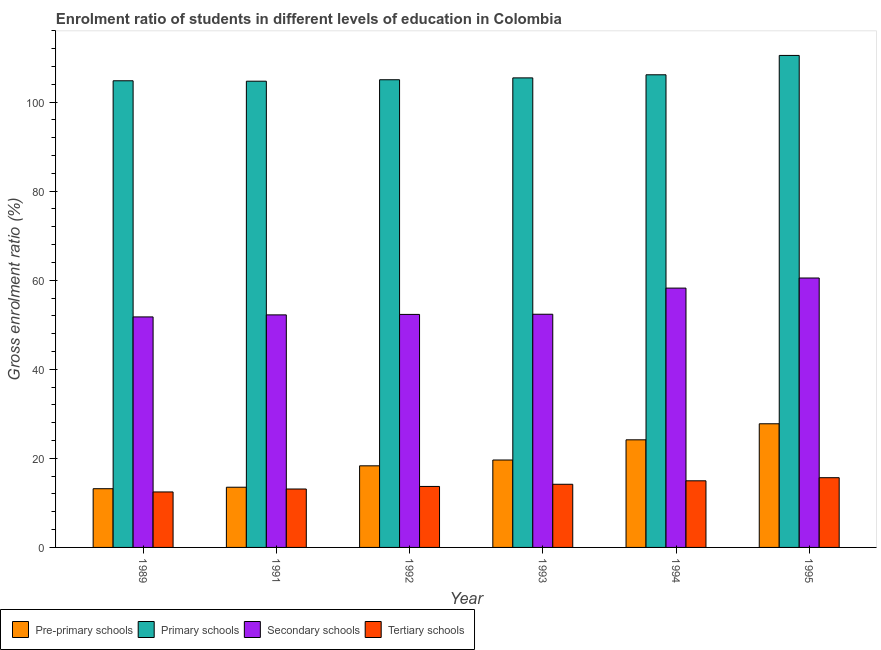How many groups of bars are there?
Offer a terse response. 6. Are the number of bars per tick equal to the number of legend labels?
Your answer should be compact. Yes. How many bars are there on the 3rd tick from the left?
Provide a succinct answer. 4. How many bars are there on the 3rd tick from the right?
Your answer should be compact. 4. What is the label of the 5th group of bars from the left?
Your answer should be compact. 1994. In how many cases, is the number of bars for a given year not equal to the number of legend labels?
Your response must be concise. 0. What is the gross enrolment ratio in tertiary schools in 1994?
Your answer should be compact. 14.96. Across all years, what is the maximum gross enrolment ratio in pre-primary schools?
Your response must be concise. 27.77. Across all years, what is the minimum gross enrolment ratio in secondary schools?
Your answer should be very brief. 51.76. What is the total gross enrolment ratio in secondary schools in the graph?
Your response must be concise. 327.41. What is the difference between the gross enrolment ratio in tertiary schools in 1989 and that in 1991?
Your response must be concise. -0.66. What is the difference between the gross enrolment ratio in tertiary schools in 1992 and the gross enrolment ratio in pre-primary schools in 1994?
Provide a short and direct response. -1.27. What is the average gross enrolment ratio in tertiary schools per year?
Your response must be concise. 14.01. In the year 1995, what is the difference between the gross enrolment ratio in primary schools and gross enrolment ratio in secondary schools?
Offer a very short reply. 0. What is the ratio of the gross enrolment ratio in primary schools in 1991 to that in 1992?
Your answer should be compact. 1. Is the difference between the gross enrolment ratio in pre-primary schools in 1991 and 1993 greater than the difference between the gross enrolment ratio in primary schools in 1991 and 1993?
Provide a short and direct response. No. What is the difference between the highest and the second highest gross enrolment ratio in secondary schools?
Your answer should be very brief. 2.27. What is the difference between the highest and the lowest gross enrolment ratio in secondary schools?
Your answer should be very brief. 8.74. What does the 2nd bar from the left in 1989 represents?
Your answer should be compact. Primary schools. What does the 1st bar from the right in 1995 represents?
Offer a terse response. Tertiary schools. Is it the case that in every year, the sum of the gross enrolment ratio in pre-primary schools and gross enrolment ratio in primary schools is greater than the gross enrolment ratio in secondary schools?
Give a very brief answer. Yes. How many bars are there?
Provide a short and direct response. 24. Are all the bars in the graph horizontal?
Offer a terse response. No. How many years are there in the graph?
Ensure brevity in your answer.  6. Are the values on the major ticks of Y-axis written in scientific E-notation?
Offer a terse response. No. Does the graph contain grids?
Offer a very short reply. No. How many legend labels are there?
Ensure brevity in your answer.  4. How are the legend labels stacked?
Provide a short and direct response. Horizontal. What is the title of the graph?
Make the answer very short. Enrolment ratio of students in different levels of education in Colombia. Does "Custom duties" appear as one of the legend labels in the graph?
Your response must be concise. No. What is the label or title of the X-axis?
Provide a succinct answer. Year. What is the Gross enrolment ratio (%) of Pre-primary schools in 1989?
Ensure brevity in your answer.  13.19. What is the Gross enrolment ratio (%) in Primary schools in 1989?
Your answer should be compact. 104.79. What is the Gross enrolment ratio (%) in Secondary schools in 1989?
Your answer should be very brief. 51.76. What is the Gross enrolment ratio (%) of Tertiary schools in 1989?
Provide a succinct answer. 12.46. What is the Gross enrolment ratio (%) of Pre-primary schools in 1991?
Give a very brief answer. 13.52. What is the Gross enrolment ratio (%) in Primary schools in 1991?
Ensure brevity in your answer.  104.7. What is the Gross enrolment ratio (%) in Secondary schools in 1991?
Keep it short and to the point. 52.22. What is the Gross enrolment ratio (%) in Tertiary schools in 1991?
Your answer should be very brief. 13.12. What is the Gross enrolment ratio (%) of Pre-primary schools in 1992?
Provide a short and direct response. 18.32. What is the Gross enrolment ratio (%) in Primary schools in 1992?
Give a very brief answer. 105.02. What is the Gross enrolment ratio (%) in Secondary schools in 1992?
Provide a succinct answer. 52.32. What is the Gross enrolment ratio (%) of Tertiary schools in 1992?
Offer a terse response. 13.69. What is the Gross enrolment ratio (%) in Pre-primary schools in 1993?
Offer a very short reply. 19.63. What is the Gross enrolment ratio (%) in Primary schools in 1993?
Offer a very short reply. 105.44. What is the Gross enrolment ratio (%) in Secondary schools in 1993?
Provide a succinct answer. 52.36. What is the Gross enrolment ratio (%) in Tertiary schools in 1993?
Your answer should be very brief. 14.18. What is the Gross enrolment ratio (%) in Pre-primary schools in 1994?
Your answer should be very brief. 24.17. What is the Gross enrolment ratio (%) in Primary schools in 1994?
Your response must be concise. 106.14. What is the Gross enrolment ratio (%) of Secondary schools in 1994?
Your response must be concise. 58.23. What is the Gross enrolment ratio (%) of Tertiary schools in 1994?
Make the answer very short. 14.96. What is the Gross enrolment ratio (%) of Pre-primary schools in 1995?
Ensure brevity in your answer.  27.77. What is the Gross enrolment ratio (%) in Primary schools in 1995?
Offer a very short reply. 110.49. What is the Gross enrolment ratio (%) in Secondary schools in 1995?
Provide a succinct answer. 60.5. What is the Gross enrolment ratio (%) of Tertiary schools in 1995?
Your answer should be very brief. 15.66. Across all years, what is the maximum Gross enrolment ratio (%) in Pre-primary schools?
Provide a succinct answer. 27.77. Across all years, what is the maximum Gross enrolment ratio (%) in Primary schools?
Ensure brevity in your answer.  110.49. Across all years, what is the maximum Gross enrolment ratio (%) of Secondary schools?
Provide a succinct answer. 60.5. Across all years, what is the maximum Gross enrolment ratio (%) of Tertiary schools?
Your answer should be very brief. 15.66. Across all years, what is the minimum Gross enrolment ratio (%) of Pre-primary schools?
Make the answer very short. 13.19. Across all years, what is the minimum Gross enrolment ratio (%) in Primary schools?
Offer a very short reply. 104.7. Across all years, what is the minimum Gross enrolment ratio (%) of Secondary schools?
Give a very brief answer. 51.76. Across all years, what is the minimum Gross enrolment ratio (%) in Tertiary schools?
Provide a succinct answer. 12.46. What is the total Gross enrolment ratio (%) in Pre-primary schools in the graph?
Offer a very short reply. 116.59. What is the total Gross enrolment ratio (%) in Primary schools in the graph?
Your answer should be very brief. 636.58. What is the total Gross enrolment ratio (%) of Secondary schools in the graph?
Offer a terse response. 327.41. What is the total Gross enrolment ratio (%) of Tertiary schools in the graph?
Your answer should be compact. 84.07. What is the difference between the Gross enrolment ratio (%) in Pre-primary schools in 1989 and that in 1991?
Your answer should be very brief. -0.33. What is the difference between the Gross enrolment ratio (%) of Primary schools in 1989 and that in 1991?
Your answer should be compact. 0.1. What is the difference between the Gross enrolment ratio (%) in Secondary schools in 1989 and that in 1991?
Provide a short and direct response. -0.46. What is the difference between the Gross enrolment ratio (%) of Tertiary schools in 1989 and that in 1991?
Keep it short and to the point. -0.66. What is the difference between the Gross enrolment ratio (%) in Pre-primary schools in 1989 and that in 1992?
Give a very brief answer. -5.14. What is the difference between the Gross enrolment ratio (%) in Primary schools in 1989 and that in 1992?
Your answer should be compact. -0.23. What is the difference between the Gross enrolment ratio (%) of Secondary schools in 1989 and that in 1992?
Provide a short and direct response. -0.56. What is the difference between the Gross enrolment ratio (%) of Tertiary schools in 1989 and that in 1992?
Offer a very short reply. -1.24. What is the difference between the Gross enrolment ratio (%) of Pre-primary schools in 1989 and that in 1993?
Offer a very short reply. -6.45. What is the difference between the Gross enrolment ratio (%) in Primary schools in 1989 and that in 1993?
Provide a succinct answer. -0.65. What is the difference between the Gross enrolment ratio (%) of Secondary schools in 1989 and that in 1993?
Your response must be concise. -0.6. What is the difference between the Gross enrolment ratio (%) in Tertiary schools in 1989 and that in 1993?
Your answer should be compact. -1.72. What is the difference between the Gross enrolment ratio (%) in Pre-primary schools in 1989 and that in 1994?
Offer a terse response. -10.98. What is the difference between the Gross enrolment ratio (%) in Primary schools in 1989 and that in 1994?
Offer a terse response. -1.34. What is the difference between the Gross enrolment ratio (%) of Secondary schools in 1989 and that in 1994?
Your answer should be very brief. -6.47. What is the difference between the Gross enrolment ratio (%) of Tertiary schools in 1989 and that in 1994?
Provide a succinct answer. -2.5. What is the difference between the Gross enrolment ratio (%) in Pre-primary schools in 1989 and that in 1995?
Your answer should be compact. -14.58. What is the difference between the Gross enrolment ratio (%) of Primary schools in 1989 and that in 1995?
Your answer should be very brief. -5.69. What is the difference between the Gross enrolment ratio (%) of Secondary schools in 1989 and that in 1995?
Your answer should be compact. -8.74. What is the difference between the Gross enrolment ratio (%) in Tertiary schools in 1989 and that in 1995?
Provide a short and direct response. -3.2. What is the difference between the Gross enrolment ratio (%) in Pre-primary schools in 1991 and that in 1992?
Keep it short and to the point. -4.8. What is the difference between the Gross enrolment ratio (%) of Primary schools in 1991 and that in 1992?
Your response must be concise. -0.32. What is the difference between the Gross enrolment ratio (%) in Secondary schools in 1991 and that in 1992?
Your response must be concise. -0.1. What is the difference between the Gross enrolment ratio (%) of Tertiary schools in 1991 and that in 1992?
Provide a succinct answer. -0.57. What is the difference between the Gross enrolment ratio (%) of Pre-primary schools in 1991 and that in 1993?
Your answer should be very brief. -6.11. What is the difference between the Gross enrolment ratio (%) in Primary schools in 1991 and that in 1993?
Keep it short and to the point. -0.74. What is the difference between the Gross enrolment ratio (%) of Secondary schools in 1991 and that in 1993?
Keep it short and to the point. -0.14. What is the difference between the Gross enrolment ratio (%) in Tertiary schools in 1991 and that in 1993?
Your answer should be compact. -1.06. What is the difference between the Gross enrolment ratio (%) of Pre-primary schools in 1991 and that in 1994?
Your answer should be very brief. -10.65. What is the difference between the Gross enrolment ratio (%) of Primary schools in 1991 and that in 1994?
Give a very brief answer. -1.44. What is the difference between the Gross enrolment ratio (%) in Secondary schools in 1991 and that in 1994?
Offer a very short reply. -6.02. What is the difference between the Gross enrolment ratio (%) in Tertiary schools in 1991 and that in 1994?
Your response must be concise. -1.84. What is the difference between the Gross enrolment ratio (%) in Pre-primary schools in 1991 and that in 1995?
Provide a short and direct response. -14.25. What is the difference between the Gross enrolment ratio (%) in Primary schools in 1991 and that in 1995?
Give a very brief answer. -5.79. What is the difference between the Gross enrolment ratio (%) of Secondary schools in 1991 and that in 1995?
Make the answer very short. -8.28. What is the difference between the Gross enrolment ratio (%) in Tertiary schools in 1991 and that in 1995?
Your response must be concise. -2.54. What is the difference between the Gross enrolment ratio (%) in Pre-primary schools in 1992 and that in 1993?
Provide a succinct answer. -1.31. What is the difference between the Gross enrolment ratio (%) of Primary schools in 1992 and that in 1993?
Make the answer very short. -0.42. What is the difference between the Gross enrolment ratio (%) of Secondary schools in 1992 and that in 1993?
Your response must be concise. -0.04. What is the difference between the Gross enrolment ratio (%) in Tertiary schools in 1992 and that in 1993?
Offer a very short reply. -0.49. What is the difference between the Gross enrolment ratio (%) of Pre-primary schools in 1992 and that in 1994?
Keep it short and to the point. -5.84. What is the difference between the Gross enrolment ratio (%) in Primary schools in 1992 and that in 1994?
Your answer should be very brief. -1.11. What is the difference between the Gross enrolment ratio (%) in Secondary schools in 1992 and that in 1994?
Your answer should be very brief. -5.91. What is the difference between the Gross enrolment ratio (%) in Tertiary schools in 1992 and that in 1994?
Offer a very short reply. -1.27. What is the difference between the Gross enrolment ratio (%) of Pre-primary schools in 1992 and that in 1995?
Your answer should be very brief. -9.44. What is the difference between the Gross enrolment ratio (%) of Primary schools in 1992 and that in 1995?
Your response must be concise. -5.46. What is the difference between the Gross enrolment ratio (%) of Secondary schools in 1992 and that in 1995?
Ensure brevity in your answer.  -8.18. What is the difference between the Gross enrolment ratio (%) in Tertiary schools in 1992 and that in 1995?
Keep it short and to the point. -1.97. What is the difference between the Gross enrolment ratio (%) in Pre-primary schools in 1993 and that in 1994?
Provide a succinct answer. -4.53. What is the difference between the Gross enrolment ratio (%) in Primary schools in 1993 and that in 1994?
Keep it short and to the point. -0.7. What is the difference between the Gross enrolment ratio (%) of Secondary schools in 1993 and that in 1994?
Give a very brief answer. -5.87. What is the difference between the Gross enrolment ratio (%) in Tertiary schools in 1993 and that in 1994?
Your answer should be very brief. -0.78. What is the difference between the Gross enrolment ratio (%) of Pre-primary schools in 1993 and that in 1995?
Your answer should be compact. -8.14. What is the difference between the Gross enrolment ratio (%) in Primary schools in 1993 and that in 1995?
Give a very brief answer. -5.04. What is the difference between the Gross enrolment ratio (%) of Secondary schools in 1993 and that in 1995?
Your response must be concise. -8.14. What is the difference between the Gross enrolment ratio (%) of Tertiary schools in 1993 and that in 1995?
Provide a short and direct response. -1.48. What is the difference between the Gross enrolment ratio (%) of Pre-primary schools in 1994 and that in 1995?
Your answer should be compact. -3.6. What is the difference between the Gross enrolment ratio (%) in Primary schools in 1994 and that in 1995?
Offer a terse response. -4.35. What is the difference between the Gross enrolment ratio (%) of Secondary schools in 1994 and that in 1995?
Your response must be concise. -2.27. What is the difference between the Gross enrolment ratio (%) in Tertiary schools in 1994 and that in 1995?
Make the answer very short. -0.7. What is the difference between the Gross enrolment ratio (%) of Pre-primary schools in 1989 and the Gross enrolment ratio (%) of Primary schools in 1991?
Make the answer very short. -91.51. What is the difference between the Gross enrolment ratio (%) of Pre-primary schools in 1989 and the Gross enrolment ratio (%) of Secondary schools in 1991?
Offer a terse response. -39.03. What is the difference between the Gross enrolment ratio (%) of Pre-primary schools in 1989 and the Gross enrolment ratio (%) of Tertiary schools in 1991?
Your answer should be very brief. 0.07. What is the difference between the Gross enrolment ratio (%) in Primary schools in 1989 and the Gross enrolment ratio (%) in Secondary schools in 1991?
Your answer should be very brief. 52.57. What is the difference between the Gross enrolment ratio (%) in Primary schools in 1989 and the Gross enrolment ratio (%) in Tertiary schools in 1991?
Ensure brevity in your answer.  91.68. What is the difference between the Gross enrolment ratio (%) in Secondary schools in 1989 and the Gross enrolment ratio (%) in Tertiary schools in 1991?
Your answer should be very brief. 38.65. What is the difference between the Gross enrolment ratio (%) in Pre-primary schools in 1989 and the Gross enrolment ratio (%) in Primary schools in 1992?
Make the answer very short. -91.84. What is the difference between the Gross enrolment ratio (%) in Pre-primary schools in 1989 and the Gross enrolment ratio (%) in Secondary schools in 1992?
Ensure brevity in your answer.  -39.14. What is the difference between the Gross enrolment ratio (%) of Pre-primary schools in 1989 and the Gross enrolment ratio (%) of Tertiary schools in 1992?
Provide a succinct answer. -0.51. What is the difference between the Gross enrolment ratio (%) of Primary schools in 1989 and the Gross enrolment ratio (%) of Secondary schools in 1992?
Keep it short and to the point. 52.47. What is the difference between the Gross enrolment ratio (%) of Primary schools in 1989 and the Gross enrolment ratio (%) of Tertiary schools in 1992?
Keep it short and to the point. 91.1. What is the difference between the Gross enrolment ratio (%) of Secondary schools in 1989 and the Gross enrolment ratio (%) of Tertiary schools in 1992?
Offer a terse response. 38.07. What is the difference between the Gross enrolment ratio (%) of Pre-primary schools in 1989 and the Gross enrolment ratio (%) of Primary schools in 1993?
Offer a terse response. -92.26. What is the difference between the Gross enrolment ratio (%) of Pre-primary schools in 1989 and the Gross enrolment ratio (%) of Secondary schools in 1993?
Provide a succinct answer. -39.18. What is the difference between the Gross enrolment ratio (%) of Pre-primary schools in 1989 and the Gross enrolment ratio (%) of Tertiary schools in 1993?
Make the answer very short. -1. What is the difference between the Gross enrolment ratio (%) of Primary schools in 1989 and the Gross enrolment ratio (%) of Secondary schools in 1993?
Give a very brief answer. 52.43. What is the difference between the Gross enrolment ratio (%) in Primary schools in 1989 and the Gross enrolment ratio (%) in Tertiary schools in 1993?
Keep it short and to the point. 90.61. What is the difference between the Gross enrolment ratio (%) of Secondary schools in 1989 and the Gross enrolment ratio (%) of Tertiary schools in 1993?
Your answer should be very brief. 37.58. What is the difference between the Gross enrolment ratio (%) in Pre-primary schools in 1989 and the Gross enrolment ratio (%) in Primary schools in 1994?
Offer a very short reply. -92.95. What is the difference between the Gross enrolment ratio (%) in Pre-primary schools in 1989 and the Gross enrolment ratio (%) in Secondary schools in 1994?
Your response must be concise. -45.05. What is the difference between the Gross enrolment ratio (%) of Pre-primary schools in 1989 and the Gross enrolment ratio (%) of Tertiary schools in 1994?
Keep it short and to the point. -1.78. What is the difference between the Gross enrolment ratio (%) of Primary schools in 1989 and the Gross enrolment ratio (%) of Secondary schools in 1994?
Provide a succinct answer. 46.56. What is the difference between the Gross enrolment ratio (%) of Primary schools in 1989 and the Gross enrolment ratio (%) of Tertiary schools in 1994?
Your answer should be very brief. 89.83. What is the difference between the Gross enrolment ratio (%) in Secondary schools in 1989 and the Gross enrolment ratio (%) in Tertiary schools in 1994?
Make the answer very short. 36.8. What is the difference between the Gross enrolment ratio (%) in Pre-primary schools in 1989 and the Gross enrolment ratio (%) in Primary schools in 1995?
Your answer should be compact. -97.3. What is the difference between the Gross enrolment ratio (%) in Pre-primary schools in 1989 and the Gross enrolment ratio (%) in Secondary schools in 1995?
Offer a very short reply. -47.32. What is the difference between the Gross enrolment ratio (%) of Pre-primary schools in 1989 and the Gross enrolment ratio (%) of Tertiary schools in 1995?
Ensure brevity in your answer.  -2.48. What is the difference between the Gross enrolment ratio (%) in Primary schools in 1989 and the Gross enrolment ratio (%) in Secondary schools in 1995?
Give a very brief answer. 44.29. What is the difference between the Gross enrolment ratio (%) in Primary schools in 1989 and the Gross enrolment ratio (%) in Tertiary schools in 1995?
Your response must be concise. 89.13. What is the difference between the Gross enrolment ratio (%) in Secondary schools in 1989 and the Gross enrolment ratio (%) in Tertiary schools in 1995?
Provide a succinct answer. 36.1. What is the difference between the Gross enrolment ratio (%) of Pre-primary schools in 1991 and the Gross enrolment ratio (%) of Primary schools in 1992?
Make the answer very short. -91.5. What is the difference between the Gross enrolment ratio (%) of Pre-primary schools in 1991 and the Gross enrolment ratio (%) of Secondary schools in 1992?
Make the answer very short. -38.8. What is the difference between the Gross enrolment ratio (%) of Pre-primary schools in 1991 and the Gross enrolment ratio (%) of Tertiary schools in 1992?
Your answer should be compact. -0.17. What is the difference between the Gross enrolment ratio (%) of Primary schools in 1991 and the Gross enrolment ratio (%) of Secondary schools in 1992?
Offer a very short reply. 52.37. What is the difference between the Gross enrolment ratio (%) in Primary schools in 1991 and the Gross enrolment ratio (%) in Tertiary schools in 1992?
Your answer should be compact. 91.01. What is the difference between the Gross enrolment ratio (%) in Secondary schools in 1991 and the Gross enrolment ratio (%) in Tertiary schools in 1992?
Give a very brief answer. 38.53. What is the difference between the Gross enrolment ratio (%) in Pre-primary schools in 1991 and the Gross enrolment ratio (%) in Primary schools in 1993?
Make the answer very short. -91.92. What is the difference between the Gross enrolment ratio (%) in Pre-primary schools in 1991 and the Gross enrolment ratio (%) in Secondary schools in 1993?
Offer a terse response. -38.84. What is the difference between the Gross enrolment ratio (%) in Pre-primary schools in 1991 and the Gross enrolment ratio (%) in Tertiary schools in 1993?
Give a very brief answer. -0.66. What is the difference between the Gross enrolment ratio (%) in Primary schools in 1991 and the Gross enrolment ratio (%) in Secondary schools in 1993?
Your answer should be compact. 52.33. What is the difference between the Gross enrolment ratio (%) in Primary schools in 1991 and the Gross enrolment ratio (%) in Tertiary schools in 1993?
Your answer should be compact. 90.52. What is the difference between the Gross enrolment ratio (%) in Secondary schools in 1991 and the Gross enrolment ratio (%) in Tertiary schools in 1993?
Your response must be concise. 38.04. What is the difference between the Gross enrolment ratio (%) in Pre-primary schools in 1991 and the Gross enrolment ratio (%) in Primary schools in 1994?
Your response must be concise. -92.62. What is the difference between the Gross enrolment ratio (%) in Pre-primary schools in 1991 and the Gross enrolment ratio (%) in Secondary schools in 1994?
Offer a very short reply. -44.71. What is the difference between the Gross enrolment ratio (%) of Pre-primary schools in 1991 and the Gross enrolment ratio (%) of Tertiary schools in 1994?
Provide a short and direct response. -1.44. What is the difference between the Gross enrolment ratio (%) in Primary schools in 1991 and the Gross enrolment ratio (%) in Secondary schools in 1994?
Offer a very short reply. 46.46. What is the difference between the Gross enrolment ratio (%) in Primary schools in 1991 and the Gross enrolment ratio (%) in Tertiary schools in 1994?
Offer a terse response. 89.74. What is the difference between the Gross enrolment ratio (%) in Secondary schools in 1991 and the Gross enrolment ratio (%) in Tertiary schools in 1994?
Your response must be concise. 37.26. What is the difference between the Gross enrolment ratio (%) in Pre-primary schools in 1991 and the Gross enrolment ratio (%) in Primary schools in 1995?
Give a very brief answer. -96.97. What is the difference between the Gross enrolment ratio (%) of Pre-primary schools in 1991 and the Gross enrolment ratio (%) of Secondary schools in 1995?
Make the answer very short. -46.98. What is the difference between the Gross enrolment ratio (%) of Pre-primary schools in 1991 and the Gross enrolment ratio (%) of Tertiary schools in 1995?
Your answer should be compact. -2.14. What is the difference between the Gross enrolment ratio (%) of Primary schools in 1991 and the Gross enrolment ratio (%) of Secondary schools in 1995?
Your answer should be very brief. 44.2. What is the difference between the Gross enrolment ratio (%) in Primary schools in 1991 and the Gross enrolment ratio (%) in Tertiary schools in 1995?
Provide a succinct answer. 89.04. What is the difference between the Gross enrolment ratio (%) in Secondary schools in 1991 and the Gross enrolment ratio (%) in Tertiary schools in 1995?
Your response must be concise. 36.56. What is the difference between the Gross enrolment ratio (%) of Pre-primary schools in 1992 and the Gross enrolment ratio (%) of Primary schools in 1993?
Offer a terse response. -87.12. What is the difference between the Gross enrolment ratio (%) in Pre-primary schools in 1992 and the Gross enrolment ratio (%) in Secondary schools in 1993?
Offer a terse response. -34.04. What is the difference between the Gross enrolment ratio (%) of Pre-primary schools in 1992 and the Gross enrolment ratio (%) of Tertiary schools in 1993?
Your response must be concise. 4.14. What is the difference between the Gross enrolment ratio (%) of Primary schools in 1992 and the Gross enrolment ratio (%) of Secondary schools in 1993?
Make the answer very short. 52.66. What is the difference between the Gross enrolment ratio (%) in Primary schools in 1992 and the Gross enrolment ratio (%) in Tertiary schools in 1993?
Your response must be concise. 90.84. What is the difference between the Gross enrolment ratio (%) in Secondary schools in 1992 and the Gross enrolment ratio (%) in Tertiary schools in 1993?
Ensure brevity in your answer.  38.14. What is the difference between the Gross enrolment ratio (%) in Pre-primary schools in 1992 and the Gross enrolment ratio (%) in Primary schools in 1994?
Make the answer very short. -87.81. What is the difference between the Gross enrolment ratio (%) of Pre-primary schools in 1992 and the Gross enrolment ratio (%) of Secondary schools in 1994?
Offer a terse response. -39.91. What is the difference between the Gross enrolment ratio (%) in Pre-primary schools in 1992 and the Gross enrolment ratio (%) in Tertiary schools in 1994?
Make the answer very short. 3.36. What is the difference between the Gross enrolment ratio (%) in Primary schools in 1992 and the Gross enrolment ratio (%) in Secondary schools in 1994?
Provide a short and direct response. 46.79. What is the difference between the Gross enrolment ratio (%) of Primary schools in 1992 and the Gross enrolment ratio (%) of Tertiary schools in 1994?
Your answer should be compact. 90.06. What is the difference between the Gross enrolment ratio (%) of Secondary schools in 1992 and the Gross enrolment ratio (%) of Tertiary schools in 1994?
Offer a very short reply. 37.36. What is the difference between the Gross enrolment ratio (%) in Pre-primary schools in 1992 and the Gross enrolment ratio (%) in Primary schools in 1995?
Make the answer very short. -92.16. What is the difference between the Gross enrolment ratio (%) in Pre-primary schools in 1992 and the Gross enrolment ratio (%) in Secondary schools in 1995?
Your answer should be compact. -42.18. What is the difference between the Gross enrolment ratio (%) of Pre-primary schools in 1992 and the Gross enrolment ratio (%) of Tertiary schools in 1995?
Keep it short and to the point. 2.66. What is the difference between the Gross enrolment ratio (%) of Primary schools in 1992 and the Gross enrolment ratio (%) of Secondary schools in 1995?
Keep it short and to the point. 44.52. What is the difference between the Gross enrolment ratio (%) in Primary schools in 1992 and the Gross enrolment ratio (%) in Tertiary schools in 1995?
Your response must be concise. 89.36. What is the difference between the Gross enrolment ratio (%) of Secondary schools in 1992 and the Gross enrolment ratio (%) of Tertiary schools in 1995?
Offer a very short reply. 36.66. What is the difference between the Gross enrolment ratio (%) of Pre-primary schools in 1993 and the Gross enrolment ratio (%) of Primary schools in 1994?
Keep it short and to the point. -86.5. What is the difference between the Gross enrolment ratio (%) in Pre-primary schools in 1993 and the Gross enrolment ratio (%) in Secondary schools in 1994?
Give a very brief answer. -38.6. What is the difference between the Gross enrolment ratio (%) in Pre-primary schools in 1993 and the Gross enrolment ratio (%) in Tertiary schools in 1994?
Your answer should be very brief. 4.67. What is the difference between the Gross enrolment ratio (%) in Primary schools in 1993 and the Gross enrolment ratio (%) in Secondary schools in 1994?
Your response must be concise. 47.21. What is the difference between the Gross enrolment ratio (%) of Primary schools in 1993 and the Gross enrolment ratio (%) of Tertiary schools in 1994?
Your response must be concise. 90.48. What is the difference between the Gross enrolment ratio (%) of Secondary schools in 1993 and the Gross enrolment ratio (%) of Tertiary schools in 1994?
Your answer should be very brief. 37.4. What is the difference between the Gross enrolment ratio (%) of Pre-primary schools in 1993 and the Gross enrolment ratio (%) of Primary schools in 1995?
Offer a terse response. -90.85. What is the difference between the Gross enrolment ratio (%) in Pre-primary schools in 1993 and the Gross enrolment ratio (%) in Secondary schools in 1995?
Ensure brevity in your answer.  -40.87. What is the difference between the Gross enrolment ratio (%) of Pre-primary schools in 1993 and the Gross enrolment ratio (%) of Tertiary schools in 1995?
Make the answer very short. 3.97. What is the difference between the Gross enrolment ratio (%) in Primary schools in 1993 and the Gross enrolment ratio (%) in Secondary schools in 1995?
Your answer should be compact. 44.94. What is the difference between the Gross enrolment ratio (%) in Primary schools in 1993 and the Gross enrolment ratio (%) in Tertiary schools in 1995?
Provide a succinct answer. 89.78. What is the difference between the Gross enrolment ratio (%) of Secondary schools in 1993 and the Gross enrolment ratio (%) of Tertiary schools in 1995?
Keep it short and to the point. 36.7. What is the difference between the Gross enrolment ratio (%) of Pre-primary schools in 1994 and the Gross enrolment ratio (%) of Primary schools in 1995?
Give a very brief answer. -86.32. What is the difference between the Gross enrolment ratio (%) in Pre-primary schools in 1994 and the Gross enrolment ratio (%) in Secondary schools in 1995?
Provide a succinct answer. -36.34. What is the difference between the Gross enrolment ratio (%) in Pre-primary schools in 1994 and the Gross enrolment ratio (%) in Tertiary schools in 1995?
Give a very brief answer. 8.5. What is the difference between the Gross enrolment ratio (%) of Primary schools in 1994 and the Gross enrolment ratio (%) of Secondary schools in 1995?
Your answer should be compact. 45.63. What is the difference between the Gross enrolment ratio (%) of Primary schools in 1994 and the Gross enrolment ratio (%) of Tertiary schools in 1995?
Offer a very short reply. 90.48. What is the difference between the Gross enrolment ratio (%) in Secondary schools in 1994 and the Gross enrolment ratio (%) in Tertiary schools in 1995?
Make the answer very short. 42.57. What is the average Gross enrolment ratio (%) in Pre-primary schools per year?
Your answer should be very brief. 19.43. What is the average Gross enrolment ratio (%) of Primary schools per year?
Provide a succinct answer. 106.1. What is the average Gross enrolment ratio (%) of Secondary schools per year?
Provide a short and direct response. 54.57. What is the average Gross enrolment ratio (%) in Tertiary schools per year?
Ensure brevity in your answer.  14.01. In the year 1989, what is the difference between the Gross enrolment ratio (%) of Pre-primary schools and Gross enrolment ratio (%) of Primary schools?
Make the answer very short. -91.61. In the year 1989, what is the difference between the Gross enrolment ratio (%) of Pre-primary schools and Gross enrolment ratio (%) of Secondary schools?
Your answer should be very brief. -38.58. In the year 1989, what is the difference between the Gross enrolment ratio (%) of Pre-primary schools and Gross enrolment ratio (%) of Tertiary schools?
Provide a succinct answer. 0.73. In the year 1989, what is the difference between the Gross enrolment ratio (%) of Primary schools and Gross enrolment ratio (%) of Secondary schools?
Provide a succinct answer. 53.03. In the year 1989, what is the difference between the Gross enrolment ratio (%) in Primary schools and Gross enrolment ratio (%) in Tertiary schools?
Offer a very short reply. 92.34. In the year 1989, what is the difference between the Gross enrolment ratio (%) in Secondary schools and Gross enrolment ratio (%) in Tertiary schools?
Keep it short and to the point. 39.31. In the year 1991, what is the difference between the Gross enrolment ratio (%) in Pre-primary schools and Gross enrolment ratio (%) in Primary schools?
Provide a succinct answer. -91.18. In the year 1991, what is the difference between the Gross enrolment ratio (%) of Pre-primary schools and Gross enrolment ratio (%) of Secondary schools?
Provide a succinct answer. -38.7. In the year 1991, what is the difference between the Gross enrolment ratio (%) in Pre-primary schools and Gross enrolment ratio (%) in Tertiary schools?
Keep it short and to the point. 0.4. In the year 1991, what is the difference between the Gross enrolment ratio (%) in Primary schools and Gross enrolment ratio (%) in Secondary schools?
Your answer should be very brief. 52.48. In the year 1991, what is the difference between the Gross enrolment ratio (%) of Primary schools and Gross enrolment ratio (%) of Tertiary schools?
Give a very brief answer. 91.58. In the year 1991, what is the difference between the Gross enrolment ratio (%) in Secondary schools and Gross enrolment ratio (%) in Tertiary schools?
Your answer should be compact. 39.1. In the year 1992, what is the difference between the Gross enrolment ratio (%) in Pre-primary schools and Gross enrolment ratio (%) in Primary schools?
Provide a short and direct response. -86.7. In the year 1992, what is the difference between the Gross enrolment ratio (%) in Pre-primary schools and Gross enrolment ratio (%) in Secondary schools?
Provide a succinct answer. -34. In the year 1992, what is the difference between the Gross enrolment ratio (%) in Pre-primary schools and Gross enrolment ratio (%) in Tertiary schools?
Provide a succinct answer. 4.63. In the year 1992, what is the difference between the Gross enrolment ratio (%) of Primary schools and Gross enrolment ratio (%) of Secondary schools?
Keep it short and to the point. 52.7. In the year 1992, what is the difference between the Gross enrolment ratio (%) of Primary schools and Gross enrolment ratio (%) of Tertiary schools?
Your answer should be compact. 91.33. In the year 1992, what is the difference between the Gross enrolment ratio (%) in Secondary schools and Gross enrolment ratio (%) in Tertiary schools?
Provide a short and direct response. 38.63. In the year 1993, what is the difference between the Gross enrolment ratio (%) of Pre-primary schools and Gross enrolment ratio (%) of Primary schools?
Make the answer very short. -85.81. In the year 1993, what is the difference between the Gross enrolment ratio (%) of Pre-primary schools and Gross enrolment ratio (%) of Secondary schools?
Your response must be concise. -32.73. In the year 1993, what is the difference between the Gross enrolment ratio (%) of Pre-primary schools and Gross enrolment ratio (%) of Tertiary schools?
Keep it short and to the point. 5.45. In the year 1993, what is the difference between the Gross enrolment ratio (%) of Primary schools and Gross enrolment ratio (%) of Secondary schools?
Provide a short and direct response. 53.08. In the year 1993, what is the difference between the Gross enrolment ratio (%) of Primary schools and Gross enrolment ratio (%) of Tertiary schools?
Keep it short and to the point. 91.26. In the year 1993, what is the difference between the Gross enrolment ratio (%) in Secondary schools and Gross enrolment ratio (%) in Tertiary schools?
Provide a short and direct response. 38.18. In the year 1994, what is the difference between the Gross enrolment ratio (%) of Pre-primary schools and Gross enrolment ratio (%) of Primary schools?
Provide a short and direct response. -81.97. In the year 1994, what is the difference between the Gross enrolment ratio (%) of Pre-primary schools and Gross enrolment ratio (%) of Secondary schools?
Offer a terse response. -34.07. In the year 1994, what is the difference between the Gross enrolment ratio (%) of Pre-primary schools and Gross enrolment ratio (%) of Tertiary schools?
Offer a terse response. 9.2. In the year 1994, what is the difference between the Gross enrolment ratio (%) of Primary schools and Gross enrolment ratio (%) of Secondary schools?
Offer a terse response. 47.9. In the year 1994, what is the difference between the Gross enrolment ratio (%) in Primary schools and Gross enrolment ratio (%) in Tertiary schools?
Make the answer very short. 91.17. In the year 1994, what is the difference between the Gross enrolment ratio (%) in Secondary schools and Gross enrolment ratio (%) in Tertiary schools?
Give a very brief answer. 43.27. In the year 1995, what is the difference between the Gross enrolment ratio (%) of Pre-primary schools and Gross enrolment ratio (%) of Primary schools?
Ensure brevity in your answer.  -82.72. In the year 1995, what is the difference between the Gross enrolment ratio (%) in Pre-primary schools and Gross enrolment ratio (%) in Secondary schools?
Give a very brief answer. -32.74. In the year 1995, what is the difference between the Gross enrolment ratio (%) in Pre-primary schools and Gross enrolment ratio (%) in Tertiary schools?
Your response must be concise. 12.11. In the year 1995, what is the difference between the Gross enrolment ratio (%) of Primary schools and Gross enrolment ratio (%) of Secondary schools?
Your answer should be compact. 49.98. In the year 1995, what is the difference between the Gross enrolment ratio (%) of Primary schools and Gross enrolment ratio (%) of Tertiary schools?
Keep it short and to the point. 94.82. In the year 1995, what is the difference between the Gross enrolment ratio (%) in Secondary schools and Gross enrolment ratio (%) in Tertiary schools?
Make the answer very short. 44.84. What is the ratio of the Gross enrolment ratio (%) of Pre-primary schools in 1989 to that in 1991?
Keep it short and to the point. 0.98. What is the ratio of the Gross enrolment ratio (%) of Primary schools in 1989 to that in 1991?
Provide a short and direct response. 1. What is the ratio of the Gross enrolment ratio (%) in Tertiary schools in 1989 to that in 1991?
Offer a terse response. 0.95. What is the ratio of the Gross enrolment ratio (%) in Pre-primary schools in 1989 to that in 1992?
Offer a terse response. 0.72. What is the ratio of the Gross enrolment ratio (%) of Primary schools in 1989 to that in 1992?
Your answer should be compact. 1. What is the ratio of the Gross enrolment ratio (%) in Secondary schools in 1989 to that in 1992?
Keep it short and to the point. 0.99. What is the ratio of the Gross enrolment ratio (%) in Tertiary schools in 1989 to that in 1992?
Give a very brief answer. 0.91. What is the ratio of the Gross enrolment ratio (%) in Pre-primary schools in 1989 to that in 1993?
Your answer should be compact. 0.67. What is the ratio of the Gross enrolment ratio (%) in Primary schools in 1989 to that in 1993?
Your answer should be very brief. 0.99. What is the ratio of the Gross enrolment ratio (%) in Tertiary schools in 1989 to that in 1993?
Provide a succinct answer. 0.88. What is the ratio of the Gross enrolment ratio (%) of Pre-primary schools in 1989 to that in 1994?
Keep it short and to the point. 0.55. What is the ratio of the Gross enrolment ratio (%) of Primary schools in 1989 to that in 1994?
Ensure brevity in your answer.  0.99. What is the ratio of the Gross enrolment ratio (%) of Tertiary schools in 1989 to that in 1994?
Your response must be concise. 0.83. What is the ratio of the Gross enrolment ratio (%) of Pre-primary schools in 1989 to that in 1995?
Offer a very short reply. 0.47. What is the ratio of the Gross enrolment ratio (%) in Primary schools in 1989 to that in 1995?
Your answer should be compact. 0.95. What is the ratio of the Gross enrolment ratio (%) of Secondary schools in 1989 to that in 1995?
Your response must be concise. 0.86. What is the ratio of the Gross enrolment ratio (%) of Tertiary schools in 1989 to that in 1995?
Offer a very short reply. 0.8. What is the ratio of the Gross enrolment ratio (%) in Pre-primary schools in 1991 to that in 1992?
Your response must be concise. 0.74. What is the ratio of the Gross enrolment ratio (%) in Secondary schools in 1991 to that in 1992?
Ensure brevity in your answer.  1. What is the ratio of the Gross enrolment ratio (%) in Tertiary schools in 1991 to that in 1992?
Ensure brevity in your answer.  0.96. What is the ratio of the Gross enrolment ratio (%) of Pre-primary schools in 1991 to that in 1993?
Make the answer very short. 0.69. What is the ratio of the Gross enrolment ratio (%) in Secondary schools in 1991 to that in 1993?
Offer a terse response. 1. What is the ratio of the Gross enrolment ratio (%) in Tertiary schools in 1991 to that in 1993?
Make the answer very short. 0.93. What is the ratio of the Gross enrolment ratio (%) of Pre-primary schools in 1991 to that in 1994?
Provide a short and direct response. 0.56. What is the ratio of the Gross enrolment ratio (%) of Primary schools in 1991 to that in 1994?
Ensure brevity in your answer.  0.99. What is the ratio of the Gross enrolment ratio (%) of Secondary schools in 1991 to that in 1994?
Ensure brevity in your answer.  0.9. What is the ratio of the Gross enrolment ratio (%) in Tertiary schools in 1991 to that in 1994?
Keep it short and to the point. 0.88. What is the ratio of the Gross enrolment ratio (%) in Pre-primary schools in 1991 to that in 1995?
Provide a succinct answer. 0.49. What is the ratio of the Gross enrolment ratio (%) of Primary schools in 1991 to that in 1995?
Your answer should be compact. 0.95. What is the ratio of the Gross enrolment ratio (%) of Secondary schools in 1991 to that in 1995?
Make the answer very short. 0.86. What is the ratio of the Gross enrolment ratio (%) in Tertiary schools in 1991 to that in 1995?
Ensure brevity in your answer.  0.84. What is the ratio of the Gross enrolment ratio (%) of Pre-primary schools in 1992 to that in 1993?
Give a very brief answer. 0.93. What is the ratio of the Gross enrolment ratio (%) in Primary schools in 1992 to that in 1993?
Offer a very short reply. 1. What is the ratio of the Gross enrolment ratio (%) in Tertiary schools in 1992 to that in 1993?
Make the answer very short. 0.97. What is the ratio of the Gross enrolment ratio (%) in Pre-primary schools in 1992 to that in 1994?
Provide a succinct answer. 0.76. What is the ratio of the Gross enrolment ratio (%) in Secondary schools in 1992 to that in 1994?
Provide a short and direct response. 0.9. What is the ratio of the Gross enrolment ratio (%) of Tertiary schools in 1992 to that in 1994?
Offer a very short reply. 0.92. What is the ratio of the Gross enrolment ratio (%) of Pre-primary schools in 1992 to that in 1995?
Give a very brief answer. 0.66. What is the ratio of the Gross enrolment ratio (%) in Primary schools in 1992 to that in 1995?
Offer a very short reply. 0.95. What is the ratio of the Gross enrolment ratio (%) of Secondary schools in 1992 to that in 1995?
Your answer should be very brief. 0.86. What is the ratio of the Gross enrolment ratio (%) in Tertiary schools in 1992 to that in 1995?
Provide a succinct answer. 0.87. What is the ratio of the Gross enrolment ratio (%) in Pre-primary schools in 1993 to that in 1994?
Offer a terse response. 0.81. What is the ratio of the Gross enrolment ratio (%) of Secondary schools in 1993 to that in 1994?
Offer a very short reply. 0.9. What is the ratio of the Gross enrolment ratio (%) in Tertiary schools in 1993 to that in 1994?
Keep it short and to the point. 0.95. What is the ratio of the Gross enrolment ratio (%) of Pre-primary schools in 1993 to that in 1995?
Ensure brevity in your answer.  0.71. What is the ratio of the Gross enrolment ratio (%) in Primary schools in 1993 to that in 1995?
Your answer should be compact. 0.95. What is the ratio of the Gross enrolment ratio (%) of Secondary schools in 1993 to that in 1995?
Make the answer very short. 0.87. What is the ratio of the Gross enrolment ratio (%) of Tertiary schools in 1993 to that in 1995?
Offer a very short reply. 0.91. What is the ratio of the Gross enrolment ratio (%) in Pre-primary schools in 1994 to that in 1995?
Keep it short and to the point. 0.87. What is the ratio of the Gross enrolment ratio (%) of Primary schools in 1994 to that in 1995?
Keep it short and to the point. 0.96. What is the ratio of the Gross enrolment ratio (%) of Secondary schools in 1994 to that in 1995?
Your answer should be compact. 0.96. What is the ratio of the Gross enrolment ratio (%) in Tertiary schools in 1994 to that in 1995?
Give a very brief answer. 0.96. What is the difference between the highest and the second highest Gross enrolment ratio (%) of Pre-primary schools?
Provide a short and direct response. 3.6. What is the difference between the highest and the second highest Gross enrolment ratio (%) of Primary schools?
Keep it short and to the point. 4.35. What is the difference between the highest and the second highest Gross enrolment ratio (%) in Secondary schools?
Offer a very short reply. 2.27. What is the difference between the highest and the second highest Gross enrolment ratio (%) of Tertiary schools?
Give a very brief answer. 0.7. What is the difference between the highest and the lowest Gross enrolment ratio (%) in Pre-primary schools?
Your answer should be compact. 14.58. What is the difference between the highest and the lowest Gross enrolment ratio (%) of Primary schools?
Make the answer very short. 5.79. What is the difference between the highest and the lowest Gross enrolment ratio (%) of Secondary schools?
Your answer should be very brief. 8.74. What is the difference between the highest and the lowest Gross enrolment ratio (%) of Tertiary schools?
Your response must be concise. 3.2. 